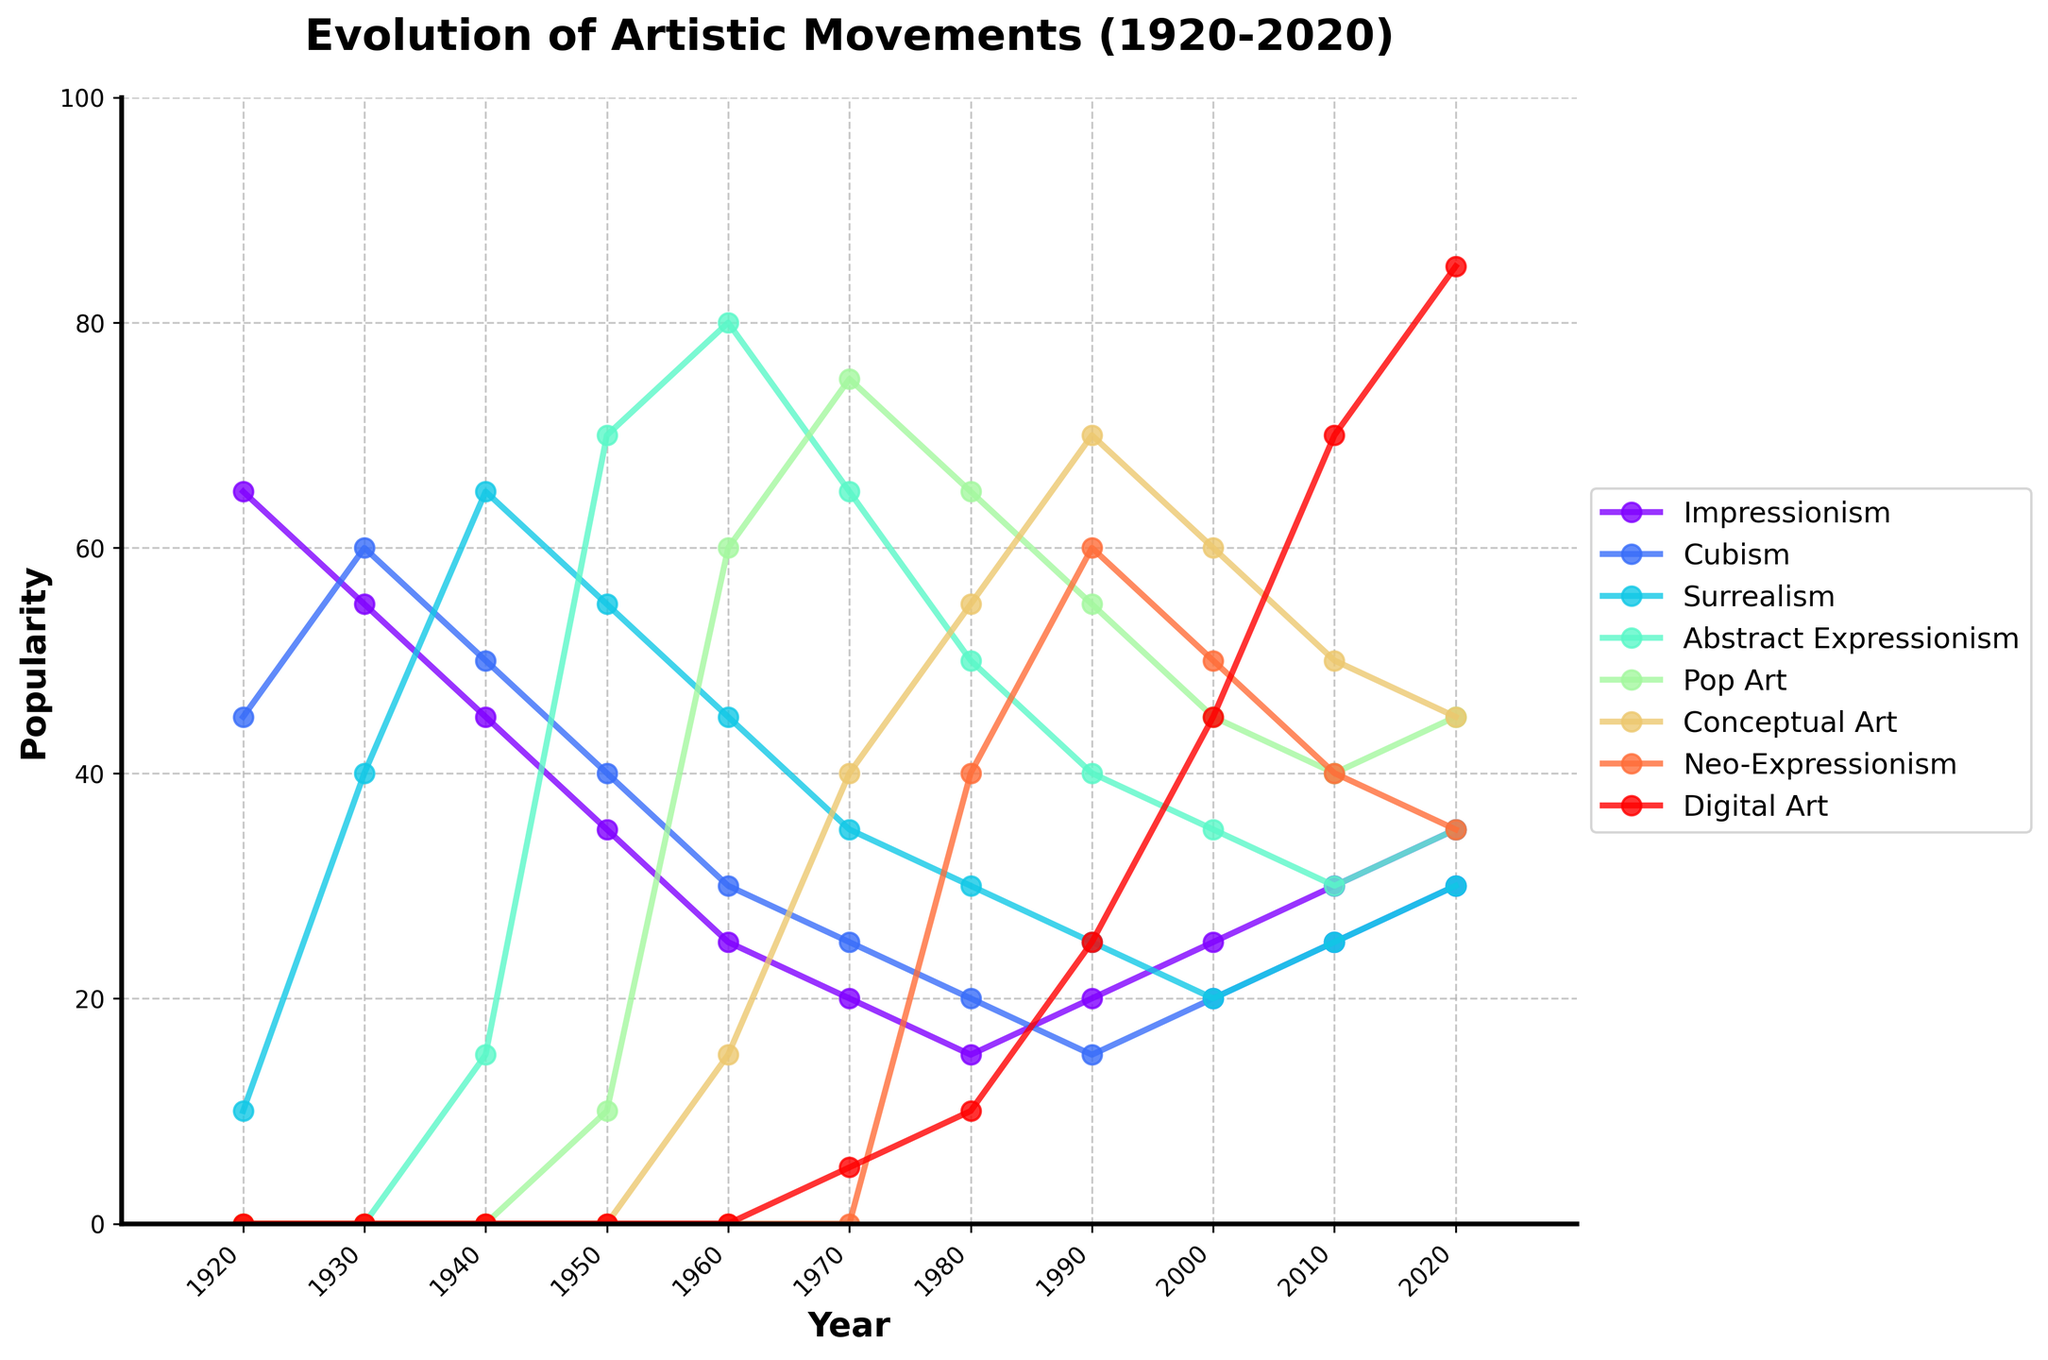What artistic movement was the pioneer in 1920, and what was its popularity score? The highest point on the graph in 1920 indicates the popularity of Impressionism, which is at 65. Compared to the other movements, Impressionism leads the popularity chart in 1920.
Answer: Impressionism, 65 Which artistic movement saw the most significant increase in popularity from 1920 to 1930? By comparing the difference in the popularity score from 1920 to 1930 for all movements, Surrealism increased from 10 to 40, a jump of 30 points, the largest among all movements.
Answer: Surrealism In which decade did Pop Art first surpass 50 in popularity? Observing Pop Art's trajectory, it surpasses 50 in the year 1960, thus the 1960s is the decade when Pop Art first surpassed 50 in popularity.
Answer: 1960s Between Abstract Expressionism and Cubism, which movement was more popular in 1970, and by how much? In 1970, Abstract Expressionism's score is 65, and Cubism's is 25. By subtracting Cubism's score from Abstract Expressionism, we get 65 - 25 = 40. So, Abstract Expressionism is more popular by 40 points.
Answer: Abstract Expressionism, 40 What is the average popularity of Neo-Expressionism from 1980 to 2000? Summing Neo-Expressionism's points for 1980, 1990, and 2000: 40, 60, and 50 respectively, yields 150. Dividing by the number of years (3), we get 150 / 3 = 50.
Answer: 50 Which artistic movement had the highest popularity in 2020, and what was its value? In 2020, the highest popularity score on the vertical axis belongs to Digital Art, with a value of 85.
Answer: Digital Art, 85 By how much did Conceptual Art's popularity change from 1970 to 1990? Conceptual Art's score in 1970 was 40, and in 1990 it was 70. Subtracting the earlier score from the later score, we get 70 - 40 = 30.
Answer: 30 In which year did Abstract Expressionism reach its peak popularity, and what was its peak score? Looking at Abstract Expressionism's trajectory, it reaches the maximum score of 80 in the year 1960.
Answer: 1960, 80 Comparing the decade of 1940 and 1950, which artistic movement had a decline in popularity, and by how much in total? Impressionism's score decreases from 45 in 1940 to 35 in 1950, resulting in a decline of 10 points. Similarly, Cubism drops from 50 in 1940 to 40 in 1950, a decline of 10 points as well. Both Impressionism and Cubism had a decline of 10 points.
Answer: Impressionism and Cubism, 10 